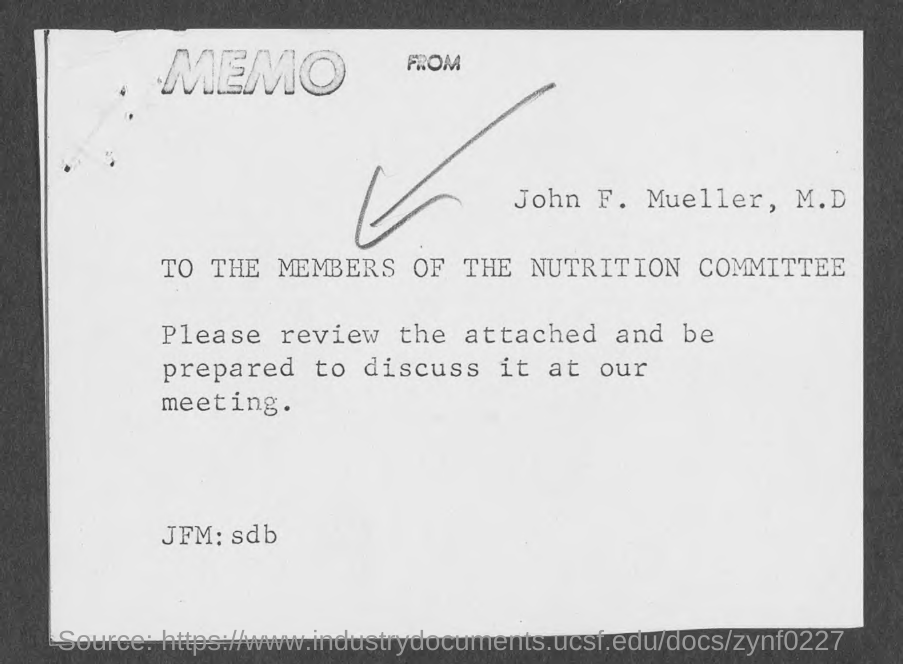Specify some key components in this picture. For the members of the nutrition committee is this memo addressed. 